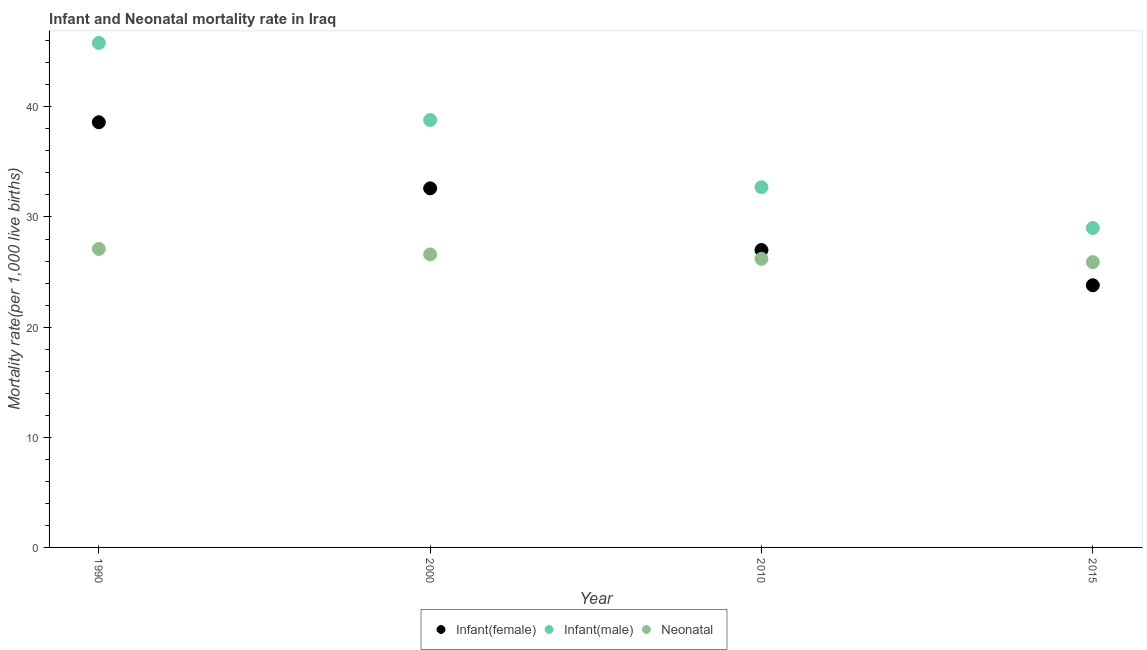Is the number of dotlines equal to the number of legend labels?
Your answer should be very brief. Yes. What is the neonatal mortality rate in 1990?
Ensure brevity in your answer.  27.1. Across all years, what is the maximum infant mortality rate(female)?
Make the answer very short. 38.6. Across all years, what is the minimum infant mortality rate(male)?
Keep it short and to the point. 29. In which year was the infant mortality rate(male) maximum?
Your response must be concise. 1990. In which year was the infant mortality rate(male) minimum?
Provide a succinct answer. 2015. What is the total infant mortality rate(male) in the graph?
Ensure brevity in your answer.  146.3. What is the difference between the infant mortality rate(male) in 1990 and the infant mortality rate(female) in 2000?
Your answer should be compact. 13.2. What is the average infant mortality rate(male) per year?
Your answer should be very brief. 36.58. In the year 2010, what is the difference between the infant mortality rate(male) and neonatal mortality rate?
Offer a very short reply. 6.5. In how many years, is the infant mortality rate(male) greater than 32?
Provide a short and direct response. 3. What is the ratio of the neonatal mortality rate in 1990 to that in 2015?
Your response must be concise. 1.05. Is the difference between the infant mortality rate(female) in 1990 and 2000 greater than the difference between the neonatal mortality rate in 1990 and 2000?
Give a very brief answer. Yes. What is the difference between the highest and the second highest infant mortality rate(female)?
Your answer should be very brief. 6. What is the difference between the highest and the lowest infant mortality rate(male)?
Offer a very short reply. 16.8. In how many years, is the infant mortality rate(male) greater than the average infant mortality rate(male) taken over all years?
Give a very brief answer. 2. Is the sum of the neonatal mortality rate in 2000 and 2015 greater than the maximum infant mortality rate(female) across all years?
Your response must be concise. Yes. Is it the case that in every year, the sum of the infant mortality rate(female) and infant mortality rate(male) is greater than the neonatal mortality rate?
Provide a succinct answer. Yes. Is the infant mortality rate(female) strictly less than the infant mortality rate(male) over the years?
Provide a succinct answer. Yes. What is the difference between two consecutive major ticks on the Y-axis?
Ensure brevity in your answer.  10. Are the values on the major ticks of Y-axis written in scientific E-notation?
Offer a terse response. No. Does the graph contain any zero values?
Make the answer very short. No. Does the graph contain grids?
Make the answer very short. No. How many legend labels are there?
Your answer should be very brief. 3. How are the legend labels stacked?
Provide a short and direct response. Horizontal. What is the title of the graph?
Provide a short and direct response. Infant and Neonatal mortality rate in Iraq. What is the label or title of the Y-axis?
Give a very brief answer. Mortality rate(per 1,0 live births). What is the Mortality rate(per 1,000 live births) of Infant(female) in 1990?
Offer a terse response. 38.6. What is the Mortality rate(per 1,000 live births) in Infant(male) in 1990?
Your answer should be compact. 45.8. What is the Mortality rate(per 1,000 live births) of Neonatal  in 1990?
Keep it short and to the point. 27.1. What is the Mortality rate(per 1,000 live births) in Infant(female) in 2000?
Keep it short and to the point. 32.6. What is the Mortality rate(per 1,000 live births) of Infant(male) in 2000?
Your response must be concise. 38.8. What is the Mortality rate(per 1,000 live births) in Neonatal  in 2000?
Make the answer very short. 26.6. What is the Mortality rate(per 1,000 live births) of Infant(female) in 2010?
Offer a very short reply. 27. What is the Mortality rate(per 1,000 live births) of Infant(male) in 2010?
Ensure brevity in your answer.  32.7. What is the Mortality rate(per 1,000 live births) of Neonatal  in 2010?
Your answer should be very brief. 26.2. What is the Mortality rate(per 1,000 live births) of Infant(female) in 2015?
Your answer should be compact. 23.8. What is the Mortality rate(per 1,000 live births) in Neonatal  in 2015?
Provide a succinct answer. 25.9. Across all years, what is the maximum Mortality rate(per 1,000 live births) in Infant(female)?
Offer a terse response. 38.6. Across all years, what is the maximum Mortality rate(per 1,000 live births) of Infant(male)?
Offer a very short reply. 45.8. Across all years, what is the maximum Mortality rate(per 1,000 live births) in Neonatal ?
Offer a terse response. 27.1. Across all years, what is the minimum Mortality rate(per 1,000 live births) in Infant(female)?
Provide a short and direct response. 23.8. Across all years, what is the minimum Mortality rate(per 1,000 live births) of Infant(male)?
Your answer should be compact. 29. Across all years, what is the minimum Mortality rate(per 1,000 live births) of Neonatal ?
Your response must be concise. 25.9. What is the total Mortality rate(per 1,000 live births) of Infant(female) in the graph?
Offer a very short reply. 122. What is the total Mortality rate(per 1,000 live births) of Infant(male) in the graph?
Provide a short and direct response. 146.3. What is the total Mortality rate(per 1,000 live births) in Neonatal  in the graph?
Offer a very short reply. 105.8. What is the difference between the Mortality rate(per 1,000 live births) in Infant(female) in 1990 and that in 2000?
Ensure brevity in your answer.  6. What is the difference between the Mortality rate(per 1,000 live births) of Infant(male) in 1990 and that in 2000?
Keep it short and to the point. 7. What is the difference between the Mortality rate(per 1,000 live births) in Infant(female) in 1990 and that in 2010?
Give a very brief answer. 11.6. What is the difference between the Mortality rate(per 1,000 live births) in Infant(male) in 1990 and that in 2010?
Your answer should be compact. 13.1. What is the difference between the Mortality rate(per 1,000 live births) in Infant(female) in 1990 and that in 2015?
Provide a succinct answer. 14.8. What is the difference between the Mortality rate(per 1,000 live births) in Infant(male) in 1990 and that in 2015?
Provide a succinct answer. 16.8. What is the difference between the Mortality rate(per 1,000 live births) of Infant(male) in 2000 and that in 2010?
Keep it short and to the point. 6.1. What is the difference between the Mortality rate(per 1,000 live births) of Neonatal  in 2000 and that in 2010?
Provide a short and direct response. 0.4. What is the difference between the Mortality rate(per 1,000 live births) of Infant(female) in 2000 and that in 2015?
Your answer should be very brief. 8.8. What is the difference between the Mortality rate(per 1,000 live births) of Infant(male) in 2010 and that in 2015?
Provide a succinct answer. 3.7. What is the difference between the Mortality rate(per 1,000 live births) of Neonatal  in 2010 and that in 2015?
Offer a terse response. 0.3. What is the difference between the Mortality rate(per 1,000 live births) of Infant(female) in 1990 and the Mortality rate(per 1,000 live births) of Neonatal  in 2000?
Offer a terse response. 12. What is the difference between the Mortality rate(per 1,000 live births) in Infant(female) in 1990 and the Mortality rate(per 1,000 live births) in Neonatal  in 2010?
Give a very brief answer. 12.4. What is the difference between the Mortality rate(per 1,000 live births) in Infant(male) in 1990 and the Mortality rate(per 1,000 live births) in Neonatal  in 2010?
Offer a terse response. 19.6. What is the difference between the Mortality rate(per 1,000 live births) in Infant(female) in 1990 and the Mortality rate(per 1,000 live births) in Infant(male) in 2015?
Offer a terse response. 9.6. What is the difference between the Mortality rate(per 1,000 live births) in Infant(female) in 1990 and the Mortality rate(per 1,000 live births) in Neonatal  in 2015?
Your answer should be compact. 12.7. What is the difference between the Mortality rate(per 1,000 live births) of Infant(female) in 2000 and the Mortality rate(per 1,000 live births) of Neonatal  in 2010?
Your response must be concise. 6.4. What is the difference between the Mortality rate(per 1,000 live births) of Infant(male) in 2000 and the Mortality rate(per 1,000 live births) of Neonatal  in 2010?
Your answer should be very brief. 12.6. What is the difference between the Mortality rate(per 1,000 live births) of Infant(female) in 2000 and the Mortality rate(per 1,000 live births) of Infant(male) in 2015?
Provide a short and direct response. 3.6. What is the difference between the Mortality rate(per 1,000 live births) of Infant(female) in 2010 and the Mortality rate(per 1,000 live births) of Infant(male) in 2015?
Provide a succinct answer. -2. What is the difference between the Mortality rate(per 1,000 live births) in Infant(female) in 2010 and the Mortality rate(per 1,000 live births) in Neonatal  in 2015?
Your answer should be very brief. 1.1. What is the average Mortality rate(per 1,000 live births) of Infant(female) per year?
Offer a terse response. 30.5. What is the average Mortality rate(per 1,000 live births) of Infant(male) per year?
Make the answer very short. 36.58. What is the average Mortality rate(per 1,000 live births) of Neonatal  per year?
Ensure brevity in your answer.  26.45. In the year 1990, what is the difference between the Mortality rate(per 1,000 live births) in Infant(female) and Mortality rate(per 1,000 live births) in Neonatal ?
Your response must be concise. 11.5. In the year 1990, what is the difference between the Mortality rate(per 1,000 live births) of Infant(male) and Mortality rate(per 1,000 live births) of Neonatal ?
Your response must be concise. 18.7. In the year 2000, what is the difference between the Mortality rate(per 1,000 live births) in Infant(female) and Mortality rate(per 1,000 live births) in Infant(male)?
Your answer should be very brief. -6.2. In the year 2000, what is the difference between the Mortality rate(per 1,000 live births) of Infant(female) and Mortality rate(per 1,000 live births) of Neonatal ?
Offer a terse response. 6. In the year 2000, what is the difference between the Mortality rate(per 1,000 live births) of Infant(male) and Mortality rate(per 1,000 live births) of Neonatal ?
Your answer should be very brief. 12.2. In the year 2010, what is the difference between the Mortality rate(per 1,000 live births) in Infant(female) and Mortality rate(per 1,000 live births) in Infant(male)?
Make the answer very short. -5.7. In the year 2015, what is the difference between the Mortality rate(per 1,000 live births) in Infant(female) and Mortality rate(per 1,000 live births) in Infant(male)?
Give a very brief answer. -5.2. In the year 2015, what is the difference between the Mortality rate(per 1,000 live births) of Infant(female) and Mortality rate(per 1,000 live births) of Neonatal ?
Your response must be concise. -2.1. What is the ratio of the Mortality rate(per 1,000 live births) of Infant(female) in 1990 to that in 2000?
Offer a terse response. 1.18. What is the ratio of the Mortality rate(per 1,000 live births) in Infant(male) in 1990 to that in 2000?
Ensure brevity in your answer.  1.18. What is the ratio of the Mortality rate(per 1,000 live births) in Neonatal  in 1990 to that in 2000?
Provide a succinct answer. 1.02. What is the ratio of the Mortality rate(per 1,000 live births) in Infant(female) in 1990 to that in 2010?
Your response must be concise. 1.43. What is the ratio of the Mortality rate(per 1,000 live births) of Infant(male) in 1990 to that in 2010?
Provide a succinct answer. 1.4. What is the ratio of the Mortality rate(per 1,000 live births) of Neonatal  in 1990 to that in 2010?
Your response must be concise. 1.03. What is the ratio of the Mortality rate(per 1,000 live births) of Infant(female) in 1990 to that in 2015?
Your answer should be compact. 1.62. What is the ratio of the Mortality rate(per 1,000 live births) in Infant(male) in 1990 to that in 2015?
Your answer should be compact. 1.58. What is the ratio of the Mortality rate(per 1,000 live births) in Neonatal  in 1990 to that in 2015?
Your answer should be compact. 1.05. What is the ratio of the Mortality rate(per 1,000 live births) of Infant(female) in 2000 to that in 2010?
Give a very brief answer. 1.21. What is the ratio of the Mortality rate(per 1,000 live births) of Infant(male) in 2000 to that in 2010?
Offer a very short reply. 1.19. What is the ratio of the Mortality rate(per 1,000 live births) of Neonatal  in 2000 to that in 2010?
Your answer should be very brief. 1.02. What is the ratio of the Mortality rate(per 1,000 live births) of Infant(female) in 2000 to that in 2015?
Give a very brief answer. 1.37. What is the ratio of the Mortality rate(per 1,000 live births) of Infant(male) in 2000 to that in 2015?
Give a very brief answer. 1.34. What is the ratio of the Mortality rate(per 1,000 live births) in Infant(female) in 2010 to that in 2015?
Your answer should be compact. 1.13. What is the ratio of the Mortality rate(per 1,000 live births) in Infant(male) in 2010 to that in 2015?
Your response must be concise. 1.13. What is the ratio of the Mortality rate(per 1,000 live births) of Neonatal  in 2010 to that in 2015?
Your response must be concise. 1.01. What is the difference between the highest and the second highest Mortality rate(per 1,000 live births) of Infant(female)?
Provide a short and direct response. 6. What is the difference between the highest and the second highest Mortality rate(per 1,000 live births) in Infant(male)?
Offer a terse response. 7. What is the difference between the highest and the lowest Mortality rate(per 1,000 live births) of Infant(male)?
Offer a very short reply. 16.8. What is the difference between the highest and the lowest Mortality rate(per 1,000 live births) in Neonatal ?
Offer a very short reply. 1.2. 